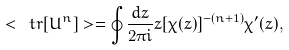<formula> <loc_0><loc_0><loc_500><loc_500>< \ t r [ U ^ { n } ] > = \oint \frac { d z } { 2 \pi i } z [ \chi ( z ) ] ^ { - ( n + 1 ) } \chi ^ { \prime } ( z ) ,</formula> 